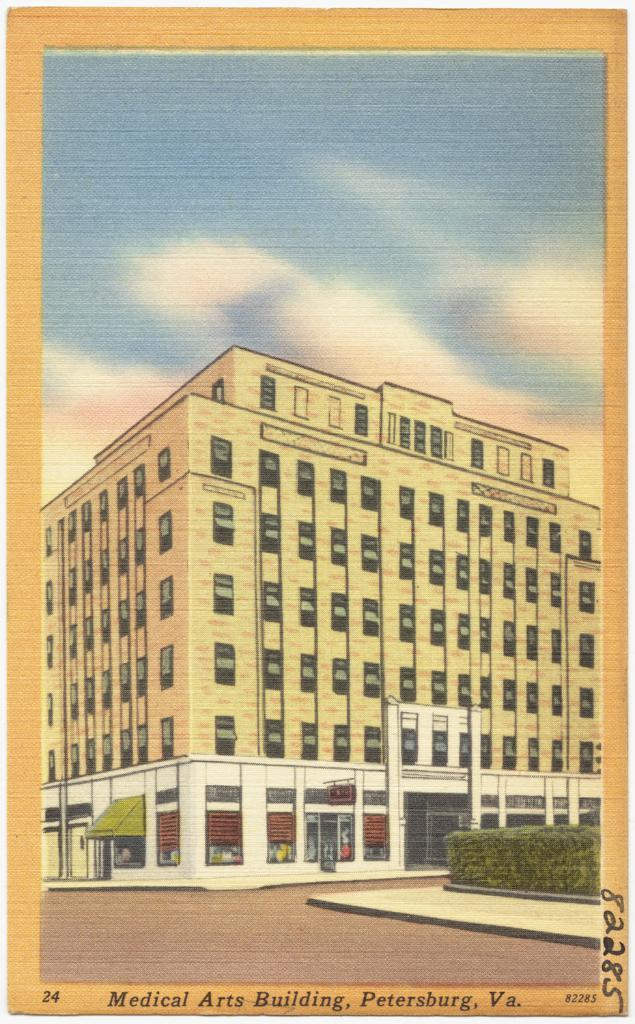What is featured in the image? There is a poster in the image. Can you describe the poster? The poster has a frame and a drawing of a building on it. What details can be observed about the building in the drawing? The building in the drawing has many windows. Are there any other elements in the drawing? Yes, there are plants on the left side of the drawing. What is visible at the top of the image? The sky is visible at the top of the image. What type of pot is used to serve the wine in the image? There is no pot or wine present in the image; it features a poster with a drawing of a building. What kind of iron is used to hold the poster in the image? There is no iron visible in the image; the poster has a frame. 